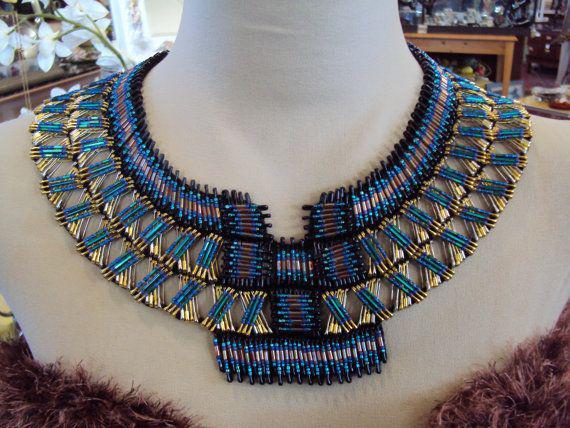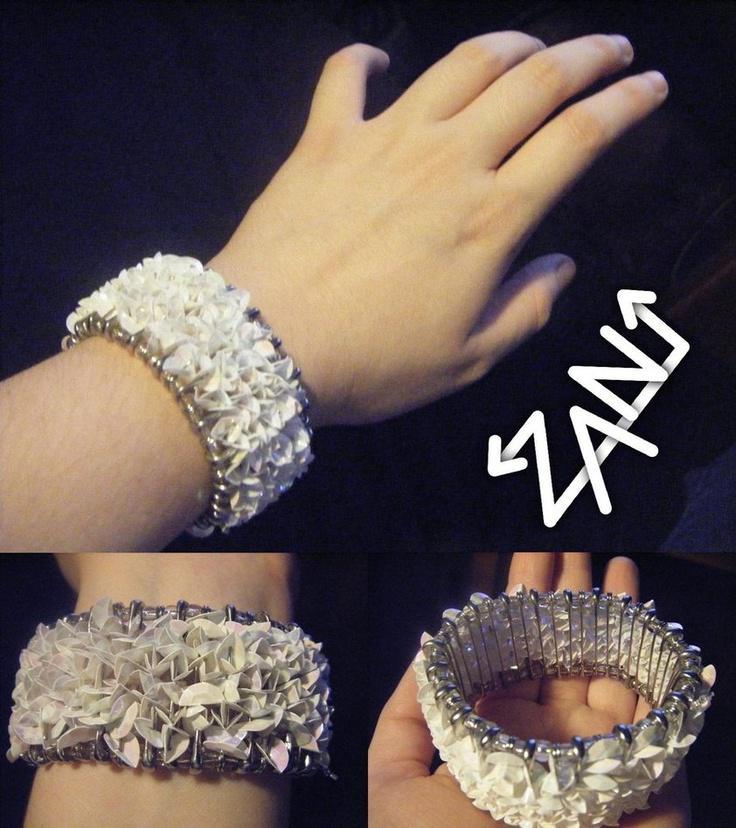The first image is the image on the left, the second image is the image on the right. Considering the images on both sides, is "One of the images shows both the legs and arms of a model." valid? Answer yes or no. No. 